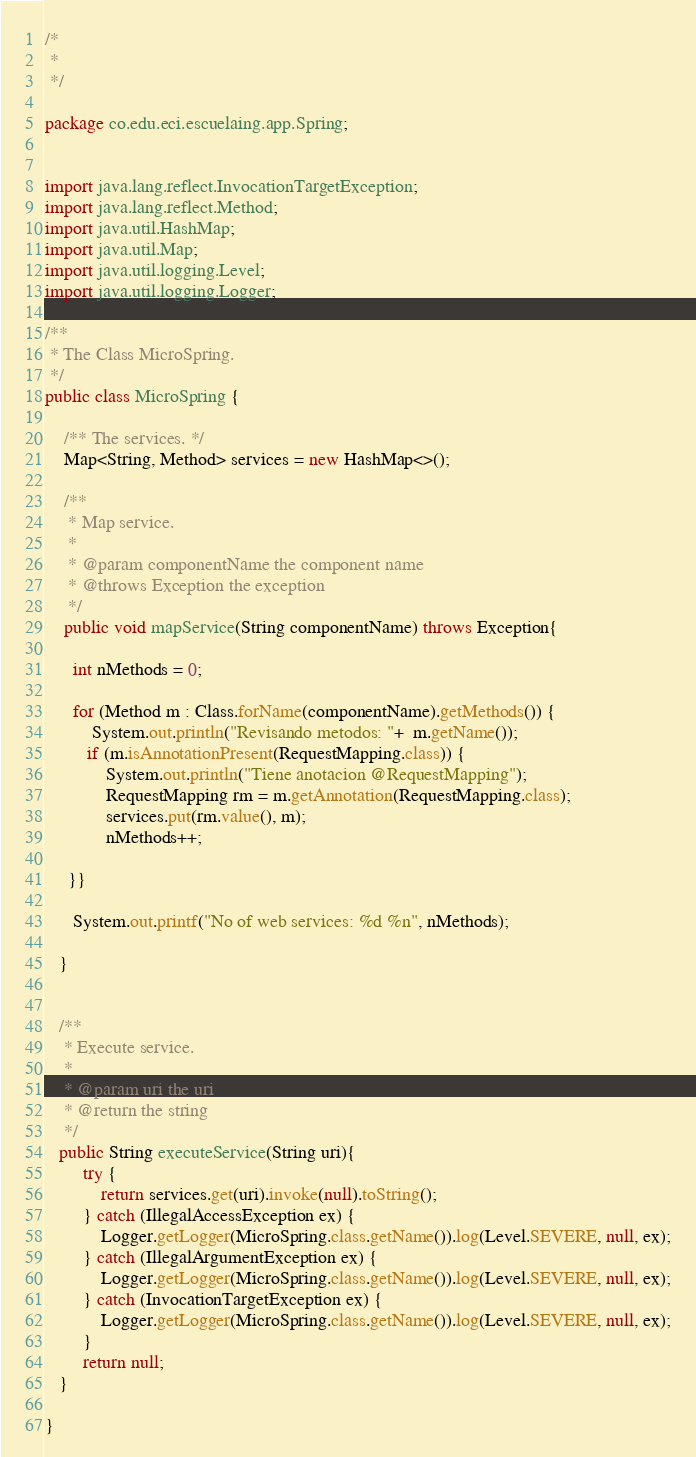Convert code to text. <code><loc_0><loc_0><loc_500><loc_500><_Java_>/*
 * 
 */

package co.edu.eci.escuelaing.app.Spring;


import java.lang.reflect.InvocationTargetException;
import java.lang.reflect.Method;
import java.util.HashMap;
import java.util.Map;
import java.util.logging.Level;
import java.util.logging.Logger;

/**
 * The Class MicroSpring.
 */
public class MicroSpring {
    
    /** The services. */
    Map<String, Method> services = new HashMap<>();
    
    /**
     * Map service.
     *
     * @param componentName the component name
     * @throws Exception the exception
     */
    public void mapService(String componentName) throws Exception{

      int nMethods = 0;

      for (Method m : Class.forName(componentName).getMethods()) {
          System.out.println("Revisando metodos: "+  m.getName());
         if (m.isAnnotationPresent(RequestMapping.class)) {
             System.out.println("Tiene anotacion @RequestMapping");
             RequestMapping rm = m.getAnnotation(RequestMapping.class);
             services.put(rm.value(), m);
             nMethods++;

     }}

      System.out.printf("No of web services: %d %n", nMethods);

   }
    

   /**
    * Execute service.
    *
    * @param uri the uri
    * @return the string
    */
   public String executeService(String uri){
        try {
            return services.get(uri).invoke(null).toString();
        } catch (IllegalAccessException ex) {
            Logger.getLogger(MicroSpring.class.getName()).log(Level.SEVERE, null, ex);
        } catch (IllegalArgumentException ex) {
            Logger.getLogger(MicroSpring.class.getName()).log(Level.SEVERE, null, ex);
        } catch (InvocationTargetException ex) {
            Logger.getLogger(MicroSpring.class.getName()).log(Level.SEVERE, null, ex);
        }
        return null;
   }
    
}
</code> 